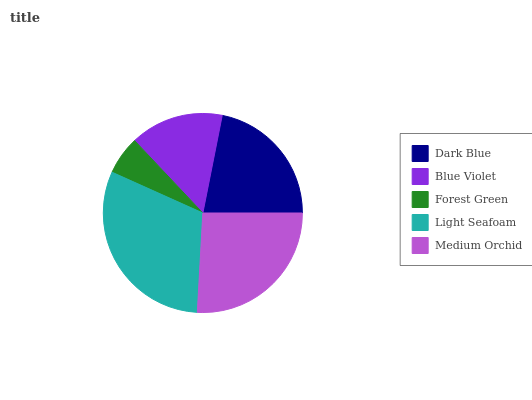Is Forest Green the minimum?
Answer yes or no. Yes. Is Light Seafoam the maximum?
Answer yes or no. Yes. Is Blue Violet the minimum?
Answer yes or no. No. Is Blue Violet the maximum?
Answer yes or no. No. Is Dark Blue greater than Blue Violet?
Answer yes or no. Yes. Is Blue Violet less than Dark Blue?
Answer yes or no. Yes. Is Blue Violet greater than Dark Blue?
Answer yes or no. No. Is Dark Blue less than Blue Violet?
Answer yes or no. No. Is Dark Blue the high median?
Answer yes or no. Yes. Is Dark Blue the low median?
Answer yes or no. Yes. Is Blue Violet the high median?
Answer yes or no. No. Is Forest Green the low median?
Answer yes or no. No. 